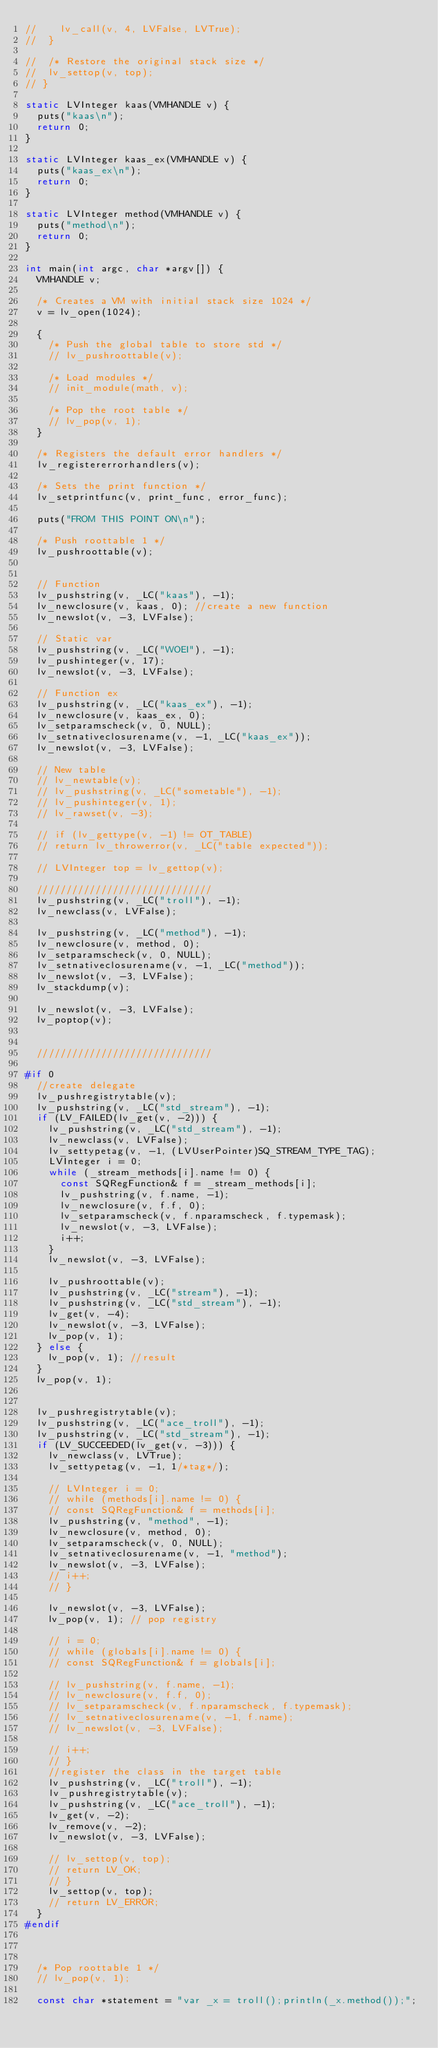Convert code to text. <code><loc_0><loc_0><loc_500><loc_500><_C_>// 		lv_call(v, 4, LVFalse, LVTrue);
// 	}

// 	/* Restore the original stack size */
// 	lv_settop(v, top);
// }

static LVInteger kaas(VMHANDLE v) {
	puts("kaas\n");
	return 0;
}

static LVInteger kaas_ex(VMHANDLE v) {
	puts("kaas_ex\n");
	return 0;
}

static LVInteger method(VMHANDLE v) {
	puts("method\n");
	return 0;
}

int main(int argc, char *argv[]) {
	VMHANDLE v;

	/* Creates a VM with initial stack size 1024 */
	v = lv_open(1024);

	{
		/* Push the global table to store std */
		// lv_pushroottable(v);

		/* Load modules */
		// init_module(math, v);

		/* Pop the root table */
		// lv_pop(v, 1);
	}

	/* Registers the default error handlers */
	lv_registererrorhandlers(v);

	/* Sets the print function */
	lv_setprintfunc(v, print_func, error_func);

	puts("FROM THIS POINT ON\n");

	/* Push roottable 1 */
	lv_pushroottable(v);


	// Function
	lv_pushstring(v, _LC("kaas"), -1);
	lv_newclosure(v, kaas, 0); //create a new function
	lv_newslot(v, -3, LVFalse);

	// Static var
	lv_pushstring(v, _LC("WOEI"), -1);
	lv_pushinteger(v, 17);
	lv_newslot(v, -3, LVFalse);

	// Function ex
	lv_pushstring(v, _LC("kaas_ex"), -1);
	lv_newclosure(v, kaas_ex, 0);
	lv_setparamscheck(v, 0, NULL);
	lv_setnativeclosurename(v, -1, _LC("kaas_ex"));
	lv_newslot(v, -3, LVFalse);

	// New table
	// lv_newtable(v);
	// lv_pushstring(v, _LC("sometable"), -1);
	// lv_pushinteger(v, 1);
	// lv_rawset(v, -3);

	// if (lv_gettype(v, -1) != OT_TABLE)
	// return lv_throwerror(v, _LC("table expected"));

	// LVInteger top = lv_gettop(v);

	//////////////////////////////
	lv_pushstring(v, _LC("troll"), -1);
	lv_newclass(v, LVFalse);

	lv_pushstring(v, _LC("method"), -1);
	lv_newclosure(v, method, 0);
	lv_setparamscheck(v, 0, NULL);
	lv_setnativeclosurename(v, -1, _LC("method"));
	lv_newslot(v, -3, LVFalse);
	lv_stackdump(v);

	lv_newslot(v, -3, LVFalse);
	lv_poptop(v);


	//////////////////////////////

#if 0
	//create delegate
	lv_pushregistrytable(v);
	lv_pushstring(v, _LC("std_stream"), -1);
	if (LV_FAILED(lv_get(v, -2))) {
		lv_pushstring(v, _LC("std_stream"), -1);
		lv_newclass(v, LVFalse);
		lv_settypetag(v, -1, (LVUserPointer)SQ_STREAM_TYPE_TAG);
		LVInteger i = 0;
		while (_stream_methods[i].name != 0) {
			const SQRegFunction& f = _stream_methods[i];
			lv_pushstring(v, f.name, -1);
			lv_newclosure(v, f.f, 0);
			lv_setparamscheck(v, f.nparamscheck, f.typemask);
			lv_newslot(v, -3, LVFalse);
			i++;
		}
		lv_newslot(v, -3, LVFalse);

		lv_pushroottable(v);
		lv_pushstring(v, _LC("stream"), -1);
		lv_pushstring(v, _LC("std_stream"), -1);
		lv_get(v, -4);
		lv_newslot(v, -3, LVFalse);
		lv_pop(v, 1);
	} else {
		lv_pop(v, 1); //result
	}
	lv_pop(v, 1);


	lv_pushregistrytable(v);
	lv_pushstring(v, _LC("ace_troll"), -1);
	lv_pushstring(v, _LC("std_stream"), -1);
	if (LV_SUCCEEDED(lv_get(v, -3))) {
		lv_newclass(v, LVTrue);
		lv_settypetag(v, -1, 1/*tag*/);

		// LVInteger i = 0;
		// while (methods[i].name != 0) {
		// const SQRegFunction& f = methods[i];
		lv_pushstring(v, "method", -1);
		lv_newclosure(v, method, 0);
		lv_setparamscheck(v, 0, NULL);
		lv_setnativeclosurename(v, -1, "method");
		lv_newslot(v, -3, LVFalse);
		// i++;
		// }

		lv_newslot(v, -3, LVFalse);
		lv_pop(v, 1); // pop registry

		// i = 0;
		// while (globals[i].name != 0) {
		// const SQRegFunction& f = globals[i];

		// lv_pushstring(v, f.name, -1);
		// lv_newclosure(v, f.f, 0);
		// lv_setparamscheck(v, f.nparamscheck, f.typemask);
		// lv_setnativeclosurename(v, -1, f.name);
		// lv_newslot(v, -3, LVFalse);

		// i++;
		// }
		//register the class in the target table
		lv_pushstring(v, _LC("troll"), -1);
		lv_pushregistrytable(v);
		lv_pushstring(v, _LC("ace_troll"), -1);
		lv_get(v, -2);
		lv_remove(v, -2);
		lv_newslot(v, -3, LVFalse);

		// lv_settop(v, top);
		// return LV_OK;
		// }
		lv_settop(v, top);
		// return LV_ERROR;
	}
#endif



	/* Pop roottable 1 */
	// lv_pop(v, 1);

	const char *statement = "var _x = troll();println(_x.method());";
</code> 